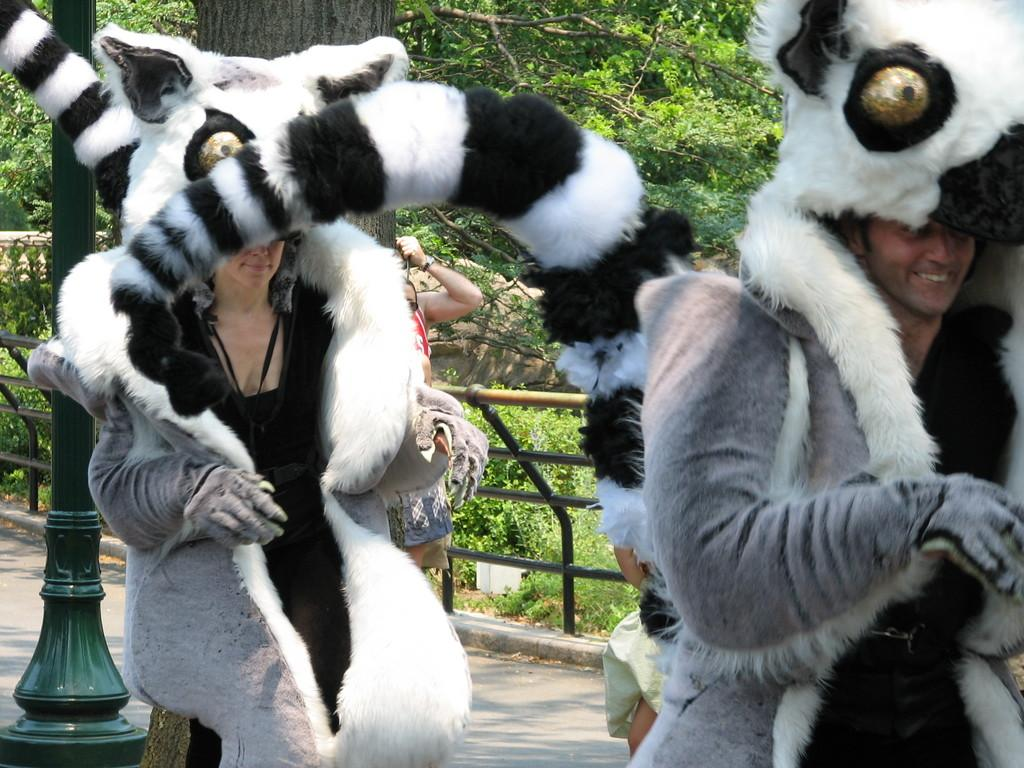How many persons are in the image wearing costumes? There are two persons in the image wearing costumes. What can be seen in the background of the image? There are people, a railing, trees, a pole, and plants visible in the background of the image. Can you describe the costumes worn by the persons in the image? Unfortunately, the facts provided do not give any details about the costumes. What type of vegetation is present in the background of the image? The vegetation in the background includes trees and plants. Where is the shelf located in the image? There is no shelf present in the image. What type of powder is being used by the persons in the image? There is no mention of powder in the image, and the persons are wearing costumes, not using any substances. 